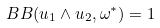Convert formula to latex. <formula><loc_0><loc_0><loc_500><loc_500>\ B B ( u _ { 1 } \wedge u _ { 2 } , \omega ^ { * } ) = 1</formula> 